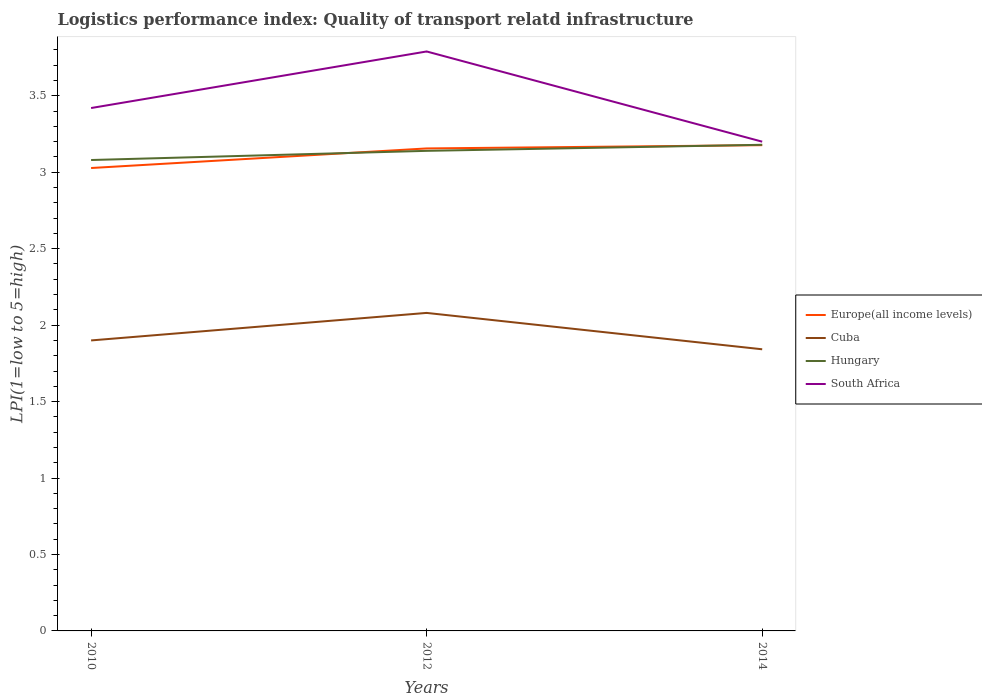Across all years, what is the maximum logistics performance index in Europe(all income levels)?
Provide a succinct answer. 3.03. In which year was the logistics performance index in Europe(all income levels) maximum?
Offer a terse response. 2010. What is the total logistics performance index in Hungary in the graph?
Offer a terse response. -0.06. What is the difference between the highest and the second highest logistics performance index in Europe(all income levels)?
Make the answer very short. 0.15. What is the difference between the highest and the lowest logistics performance index in South Africa?
Offer a terse response. 1. Is the logistics performance index in Europe(all income levels) strictly greater than the logistics performance index in Hungary over the years?
Provide a short and direct response. No. How many lines are there?
Keep it short and to the point. 4. What is the difference between two consecutive major ticks on the Y-axis?
Ensure brevity in your answer.  0.5. Are the values on the major ticks of Y-axis written in scientific E-notation?
Keep it short and to the point. No. Does the graph contain any zero values?
Offer a very short reply. No. Where does the legend appear in the graph?
Keep it short and to the point. Center right. How many legend labels are there?
Ensure brevity in your answer.  4. How are the legend labels stacked?
Ensure brevity in your answer.  Vertical. What is the title of the graph?
Your answer should be compact. Logistics performance index: Quality of transport relatd infrastructure. What is the label or title of the X-axis?
Make the answer very short. Years. What is the label or title of the Y-axis?
Offer a very short reply. LPI(1=low to 5=high). What is the LPI(1=low to 5=high) of Europe(all income levels) in 2010?
Provide a short and direct response. 3.03. What is the LPI(1=low to 5=high) of Cuba in 2010?
Your answer should be very brief. 1.9. What is the LPI(1=low to 5=high) in Hungary in 2010?
Provide a succinct answer. 3.08. What is the LPI(1=low to 5=high) of South Africa in 2010?
Give a very brief answer. 3.42. What is the LPI(1=low to 5=high) of Europe(all income levels) in 2012?
Make the answer very short. 3.16. What is the LPI(1=low to 5=high) of Cuba in 2012?
Provide a succinct answer. 2.08. What is the LPI(1=low to 5=high) in Hungary in 2012?
Ensure brevity in your answer.  3.14. What is the LPI(1=low to 5=high) of South Africa in 2012?
Your answer should be compact. 3.79. What is the LPI(1=low to 5=high) in Europe(all income levels) in 2014?
Your answer should be very brief. 3.18. What is the LPI(1=low to 5=high) in Cuba in 2014?
Provide a short and direct response. 1.84. What is the LPI(1=low to 5=high) in Hungary in 2014?
Provide a short and direct response. 3.18. What is the LPI(1=low to 5=high) of South Africa in 2014?
Keep it short and to the point. 3.2. Across all years, what is the maximum LPI(1=low to 5=high) in Europe(all income levels)?
Give a very brief answer. 3.18. Across all years, what is the maximum LPI(1=low to 5=high) of Cuba?
Provide a succinct answer. 2.08. Across all years, what is the maximum LPI(1=low to 5=high) of Hungary?
Your response must be concise. 3.18. Across all years, what is the maximum LPI(1=low to 5=high) of South Africa?
Give a very brief answer. 3.79. Across all years, what is the minimum LPI(1=low to 5=high) of Europe(all income levels)?
Your response must be concise. 3.03. Across all years, what is the minimum LPI(1=low to 5=high) in Cuba?
Ensure brevity in your answer.  1.84. Across all years, what is the minimum LPI(1=low to 5=high) in Hungary?
Provide a succinct answer. 3.08. What is the total LPI(1=low to 5=high) in Europe(all income levels) in the graph?
Your response must be concise. 9.36. What is the total LPI(1=low to 5=high) of Cuba in the graph?
Keep it short and to the point. 5.82. What is the total LPI(1=low to 5=high) in Hungary in the graph?
Offer a terse response. 9.4. What is the total LPI(1=low to 5=high) of South Africa in the graph?
Your response must be concise. 10.41. What is the difference between the LPI(1=low to 5=high) in Europe(all income levels) in 2010 and that in 2012?
Offer a terse response. -0.13. What is the difference between the LPI(1=low to 5=high) in Cuba in 2010 and that in 2012?
Offer a terse response. -0.18. What is the difference between the LPI(1=low to 5=high) in Hungary in 2010 and that in 2012?
Your answer should be compact. -0.06. What is the difference between the LPI(1=low to 5=high) of South Africa in 2010 and that in 2012?
Keep it short and to the point. -0.37. What is the difference between the LPI(1=low to 5=high) of Europe(all income levels) in 2010 and that in 2014?
Provide a short and direct response. -0.15. What is the difference between the LPI(1=low to 5=high) in Cuba in 2010 and that in 2014?
Ensure brevity in your answer.  0.06. What is the difference between the LPI(1=low to 5=high) in Hungary in 2010 and that in 2014?
Your answer should be very brief. -0.1. What is the difference between the LPI(1=low to 5=high) in South Africa in 2010 and that in 2014?
Your response must be concise. 0.22. What is the difference between the LPI(1=low to 5=high) in Europe(all income levels) in 2012 and that in 2014?
Keep it short and to the point. -0.02. What is the difference between the LPI(1=low to 5=high) in Cuba in 2012 and that in 2014?
Give a very brief answer. 0.24. What is the difference between the LPI(1=low to 5=high) in Hungary in 2012 and that in 2014?
Give a very brief answer. -0.04. What is the difference between the LPI(1=low to 5=high) in South Africa in 2012 and that in 2014?
Offer a terse response. 0.59. What is the difference between the LPI(1=low to 5=high) of Europe(all income levels) in 2010 and the LPI(1=low to 5=high) of Cuba in 2012?
Keep it short and to the point. 0.95. What is the difference between the LPI(1=low to 5=high) of Europe(all income levels) in 2010 and the LPI(1=low to 5=high) of Hungary in 2012?
Your response must be concise. -0.11. What is the difference between the LPI(1=low to 5=high) in Europe(all income levels) in 2010 and the LPI(1=low to 5=high) in South Africa in 2012?
Ensure brevity in your answer.  -0.76. What is the difference between the LPI(1=low to 5=high) of Cuba in 2010 and the LPI(1=low to 5=high) of Hungary in 2012?
Your answer should be very brief. -1.24. What is the difference between the LPI(1=low to 5=high) in Cuba in 2010 and the LPI(1=low to 5=high) in South Africa in 2012?
Provide a succinct answer. -1.89. What is the difference between the LPI(1=low to 5=high) in Hungary in 2010 and the LPI(1=low to 5=high) in South Africa in 2012?
Your answer should be compact. -0.71. What is the difference between the LPI(1=low to 5=high) in Europe(all income levels) in 2010 and the LPI(1=low to 5=high) in Cuba in 2014?
Your answer should be very brief. 1.19. What is the difference between the LPI(1=low to 5=high) of Europe(all income levels) in 2010 and the LPI(1=low to 5=high) of Hungary in 2014?
Your answer should be very brief. -0.15. What is the difference between the LPI(1=low to 5=high) in Europe(all income levels) in 2010 and the LPI(1=low to 5=high) in South Africa in 2014?
Your answer should be compact. -0.17. What is the difference between the LPI(1=low to 5=high) of Cuba in 2010 and the LPI(1=low to 5=high) of Hungary in 2014?
Give a very brief answer. -1.28. What is the difference between the LPI(1=low to 5=high) in Cuba in 2010 and the LPI(1=low to 5=high) in South Africa in 2014?
Provide a succinct answer. -1.3. What is the difference between the LPI(1=low to 5=high) in Hungary in 2010 and the LPI(1=low to 5=high) in South Africa in 2014?
Offer a terse response. -0.12. What is the difference between the LPI(1=low to 5=high) of Europe(all income levels) in 2012 and the LPI(1=low to 5=high) of Cuba in 2014?
Keep it short and to the point. 1.31. What is the difference between the LPI(1=low to 5=high) in Europe(all income levels) in 2012 and the LPI(1=low to 5=high) in Hungary in 2014?
Your response must be concise. -0.02. What is the difference between the LPI(1=low to 5=high) of Europe(all income levels) in 2012 and the LPI(1=low to 5=high) of South Africa in 2014?
Give a very brief answer. -0.04. What is the difference between the LPI(1=low to 5=high) of Cuba in 2012 and the LPI(1=low to 5=high) of Hungary in 2014?
Offer a terse response. -1.1. What is the difference between the LPI(1=low to 5=high) in Cuba in 2012 and the LPI(1=low to 5=high) in South Africa in 2014?
Your answer should be compact. -1.12. What is the difference between the LPI(1=low to 5=high) in Hungary in 2012 and the LPI(1=low to 5=high) in South Africa in 2014?
Provide a succinct answer. -0.06. What is the average LPI(1=low to 5=high) in Europe(all income levels) per year?
Your answer should be compact. 3.12. What is the average LPI(1=low to 5=high) in Cuba per year?
Offer a very short reply. 1.94. What is the average LPI(1=low to 5=high) of Hungary per year?
Your answer should be very brief. 3.13. What is the average LPI(1=low to 5=high) of South Africa per year?
Make the answer very short. 3.47. In the year 2010, what is the difference between the LPI(1=low to 5=high) in Europe(all income levels) and LPI(1=low to 5=high) in Cuba?
Your response must be concise. 1.13. In the year 2010, what is the difference between the LPI(1=low to 5=high) of Europe(all income levels) and LPI(1=low to 5=high) of Hungary?
Make the answer very short. -0.05. In the year 2010, what is the difference between the LPI(1=low to 5=high) of Europe(all income levels) and LPI(1=low to 5=high) of South Africa?
Your answer should be very brief. -0.39. In the year 2010, what is the difference between the LPI(1=low to 5=high) in Cuba and LPI(1=low to 5=high) in Hungary?
Offer a terse response. -1.18. In the year 2010, what is the difference between the LPI(1=low to 5=high) in Cuba and LPI(1=low to 5=high) in South Africa?
Your answer should be very brief. -1.52. In the year 2010, what is the difference between the LPI(1=low to 5=high) of Hungary and LPI(1=low to 5=high) of South Africa?
Provide a short and direct response. -0.34. In the year 2012, what is the difference between the LPI(1=low to 5=high) in Europe(all income levels) and LPI(1=low to 5=high) in Cuba?
Provide a succinct answer. 1.08. In the year 2012, what is the difference between the LPI(1=low to 5=high) in Europe(all income levels) and LPI(1=low to 5=high) in Hungary?
Make the answer very short. 0.02. In the year 2012, what is the difference between the LPI(1=low to 5=high) in Europe(all income levels) and LPI(1=low to 5=high) in South Africa?
Make the answer very short. -0.63. In the year 2012, what is the difference between the LPI(1=low to 5=high) in Cuba and LPI(1=low to 5=high) in Hungary?
Make the answer very short. -1.06. In the year 2012, what is the difference between the LPI(1=low to 5=high) in Cuba and LPI(1=low to 5=high) in South Africa?
Make the answer very short. -1.71. In the year 2012, what is the difference between the LPI(1=low to 5=high) in Hungary and LPI(1=low to 5=high) in South Africa?
Your response must be concise. -0.65. In the year 2014, what is the difference between the LPI(1=low to 5=high) of Europe(all income levels) and LPI(1=low to 5=high) of Cuba?
Offer a terse response. 1.33. In the year 2014, what is the difference between the LPI(1=low to 5=high) in Europe(all income levels) and LPI(1=low to 5=high) in Hungary?
Offer a terse response. -0. In the year 2014, what is the difference between the LPI(1=low to 5=high) of Europe(all income levels) and LPI(1=low to 5=high) of South Africa?
Provide a short and direct response. -0.02. In the year 2014, what is the difference between the LPI(1=low to 5=high) in Cuba and LPI(1=low to 5=high) in Hungary?
Make the answer very short. -1.34. In the year 2014, what is the difference between the LPI(1=low to 5=high) in Cuba and LPI(1=low to 5=high) in South Africa?
Provide a short and direct response. -1.36. In the year 2014, what is the difference between the LPI(1=low to 5=high) in Hungary and LPI(1=low to 5=high) in South Africa?
Your answer should be compact. -0.02. What is the ratio of the LPI(1=low to 5=high) of Europe(all income levels) in 2010 to that in 2012?
Keep it short and to the point. 0.96. What is the ratio of the LPI(1=low to 5=high) of Cuba in 2010 to that in 2012?
Keep it short and to the point. 0.91. What is the ratio of the LPI(1=low to 5=high) of Hungary in 2010 to that in 2012?
Offer a very short reply. 0.98. What is the ratio of the LPI(1=low to 5=high) in South Africa in 2010 to that in 2012?
Provide a succinct answer. 0.9. What is the ratio of the LPI(1=low to 5=high) in Europe(all income levels) in 2010 to that in 2014?
Give a very brief answer. 0.95. What is the ratio of the LPI(1=low to 5=high) in Cuba in 2010 to that in 2014?
Your answer should be very brief. 1.03. What is the ratio of the LPI(1=low to 5=high) in Hungary in 2010 to that in 2014?
Your response must be concise. 0.97. What is the ratio of the LPI(1=low to 5=high) in South Africa in 2010 to that in 2014?
Give a very brief answer. 1.07. What is the ratio of the LPI(1=low to 5=high) of Cuba in 2012 to that in 2014?
Your response must be concise. 1.13. What is the ratio of the LPI(1=low to 5=high) of Hungary in 2012 to that in 2014?
Offer a terse response. 0.99. What is the ratio of the LPI(1=low to 5=high) in South Africa in 2012 to that in 2014?
Your response must be concise. 1.18. What is the difference between the highest and the second highest LPI(1=low to 5=high) in Europe(all income levels)?
Ensure brevity in your answer.  0.02. What is the difference between the highest and the second highest LPI(1=low to 5=high) in Cuba?
Offer a terse response. 0.18. What is the difference between the highest and the second highest LPI(1=low to 5=high) of Hungary?
Provide a short and direct response. 0.04. What is the difference between the highest and the second highest LPI(1=low to 5=high) in South Africa?
Keep it short and to the point. 0.37. What is the difference between the highest and the lowest LPI(1=low to 5=high) of Europe(all income levels)?
Keep it short and to the point. 0.15. What is the difference between the highest and the lowest LPI(1=low to 5=high) of Cuba?
Offer a very short reply. 0.24. What is the difference between the highest and the lowest LPI(1=low to 5=high) in Hungary?
Your response must be concise. 0.1. What is the difference between the highest and the lowest LPI(1=low to 5=high) of South Africa?
Provide a succinct answer. 0.59. 